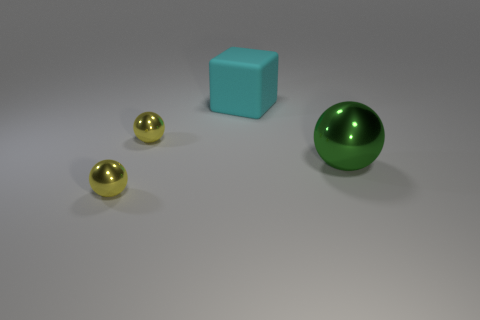What number of objects are either green things or rubber blocks? In the image, there are a total of four objects. There is one rubber block which is the blue cube and one green object which is a sphere. So, according to the question, there's only one object that is green and one object that could be considered a rubber block, making the answer 2. 